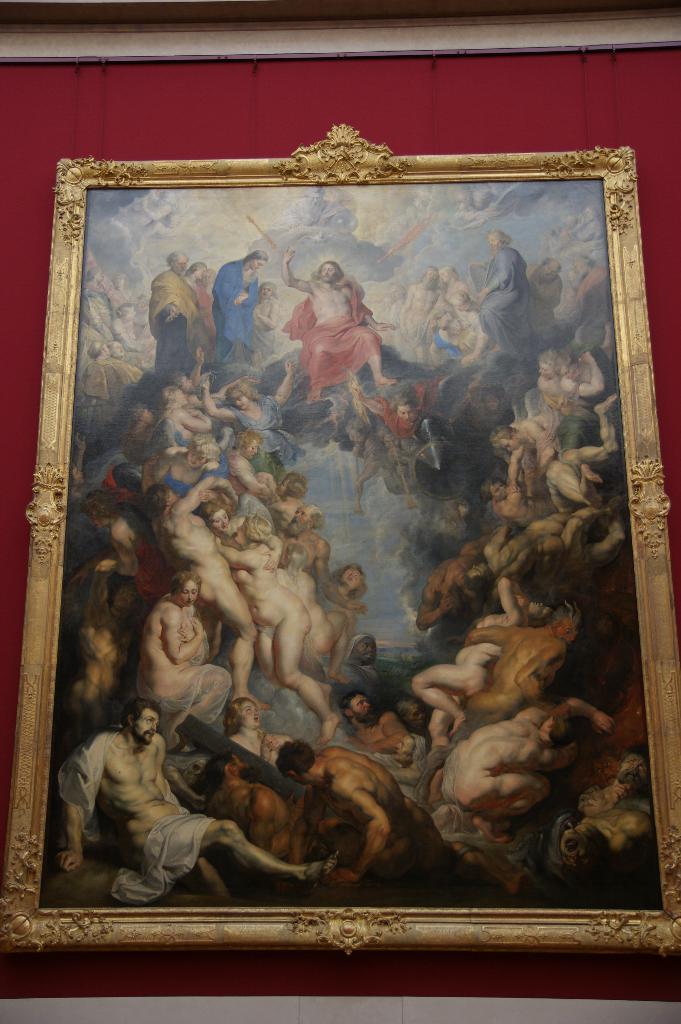In one or two sentences, can you explain what this image depicts? In this image there is a frame of a few people is hanging on the wall. 